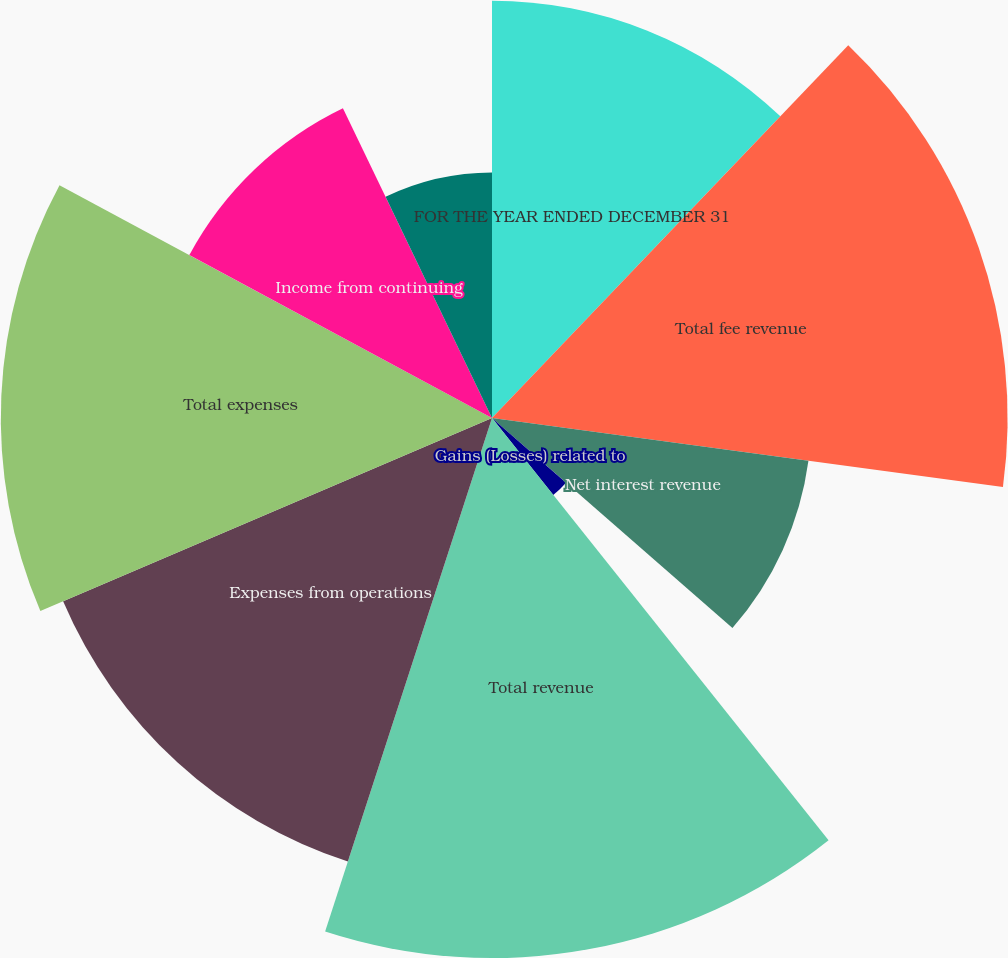<chart> <loc_0><loc_0><loc_500><loc_500><pie_chart><fcel>FOR THE YEAR ENDED DECEMBER 31<fcel>Total fee revenue<fcel>Net interest revenue<fcel>Gains (Losses) related to<fcel>Total revenue<fcel>Expenses from operations<fcel>Total expenses<fcel>Income from continuing<fcel>Income tax expense from<nl><fcel>12.14%<fcel>15.0%<fcel>9.29%<fcel>2.86%<fcel>15.71%<fcel>13.57%<fcel>14.29%<fcel>10.0%<fcel>7.14%<nl></chart> 